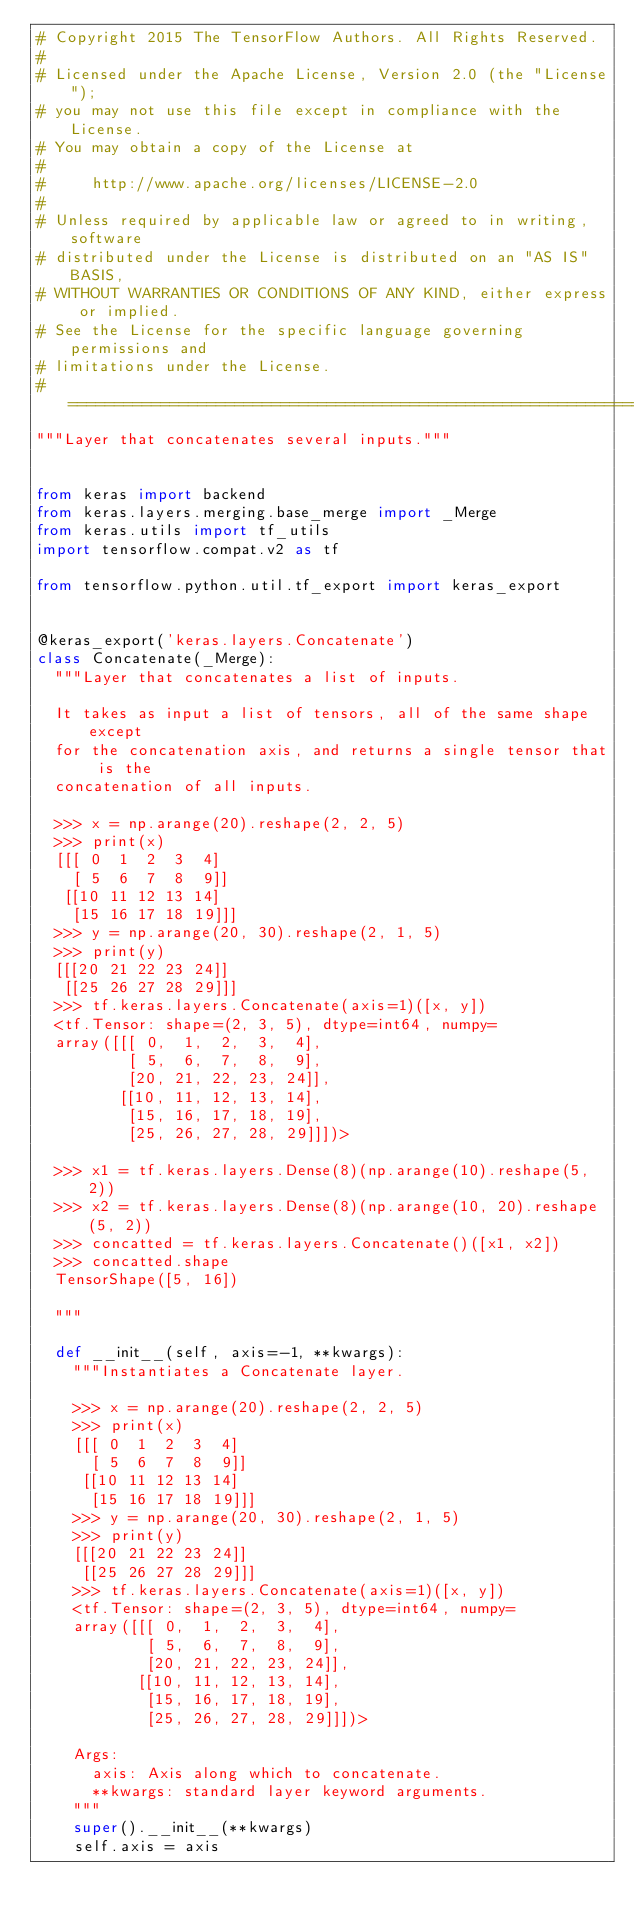<code> <loc_0><loc_0><loc_500><loc_500><_Python_># Copyright 2015 The TensorFlow Authors. All Rights Reserved.
#
# Licensed under the Apache License, Version 2.0 (the "License");
# you may not use this file except in compliance with the License.
# You may obtain a copy of the License at
#
#     http://www.apache.org/licenses/LICENSE-2.0
#
# Unless required by applicable law or agreed to in writing, software
# distributed under the License is distributed on an "AS IS" BASIS,
# WITHOUT WARRANTIES OR CONDITIONS OF ANY KIND, either express or implied.
# See the License for the specific language governing permissions and
# limitations under the License.
# ==============================================================================
"""Layer that concatenates several inputs."""


from keras import backend
from keras.layers.merging.base_merge import _Merge
from keras.utils import tf_utils
import tensorflow.compat.v2 as tf

from tensorflow.python.util.tf_export import keras_export


@keras_export('keras.layers.Concatenate')
class Concatenate(_Merge):
  """Layer that concatenates a list of inputs.

  It takes as input a list of tensors, all of the same shape except
  for the concatenation axis, and returns a single tensor that is the
  concatenation of all inputs.

  >>> x = np.arange(20).reshape(2, 2, 5)
  >>> print(x)
  [[[ 0  1  2  3  4]
    [ 5  6  7  8  9]]
   [[10 11 12 13 14]
    [15 16 17 18 19]]]
  >>> y = np.arange(20, 30).reshape(2, 1, 5)
  >>> print(y)
  [[[20 21 22 23 24]]
   [[25 26 27 28 29]]]
  >>> tf.keras.layers.Concatenate(axis=1)([x, y])
  <tf.Tensor: shape=(2, 3, 5), dtype=int64, numpy=
  array([[[ 0,  1,  2,  3,  4],
          [ 5,  6,  7,  8,  9],
          [20, 21, 22, 23, 24]],
         [[10, 11, 12, 13, 14],
          [15, 16, 17, 18, 19],
          [25, 26, 27, 28, 29]]])>

  >>> x1 = tf.keras.layers.Dense(8)(np.arange(10).reshape(5, 2))
  >>> x2 = tf.keras.layers.Dense(8)(np.arange(10, 20).reshape(5, 2))
  >>> concatted = tf.keras.layers.Concatenate()([x1, x2])
  >>> concatted.shape
  TensorShape([5, 16])

  """

  def __init__(self, axis=-1, **kwargs):
    """Instantiates a Concatenate layer.

    >>> x = np.arange(20).reshape(2, 2, 5)
    >>> print(x)
    [[[ 0  1  2  3  4]
      [ 5  6  7  8  9]]
     [[10 11 12 13 14]
      [15 16 17 18 19]]]
    >>> y = np.arange(20, 30).reshape(2, 1, 5)
    >>> print(y)
    [[[20 21 22 23 24]]
     [[25 26 27 28 29]]]
    >>> tf.keras.layers.Concatenate(axis=1)([x, y])
    <tf.Tensor: shape=(2, 3, 5), dtype=int64, numpy=
    array([[[ 0,  1,  2,  3,  4],
            [ 5,  6,  7,  8,  9],
            [20, 21, 22, 23, 24]],
           [[10, 11, 12, 13, 14],
            [15, 16, 17, 18, 19],
            [25, 26, 27, 28, 29]]])>

    Args:
      axis: Axis along which to concatenate.
      **kwargs: standard layer keyword arguments.
    """
    super().__init__(**kwargs)
    self.axis = axis</code> 